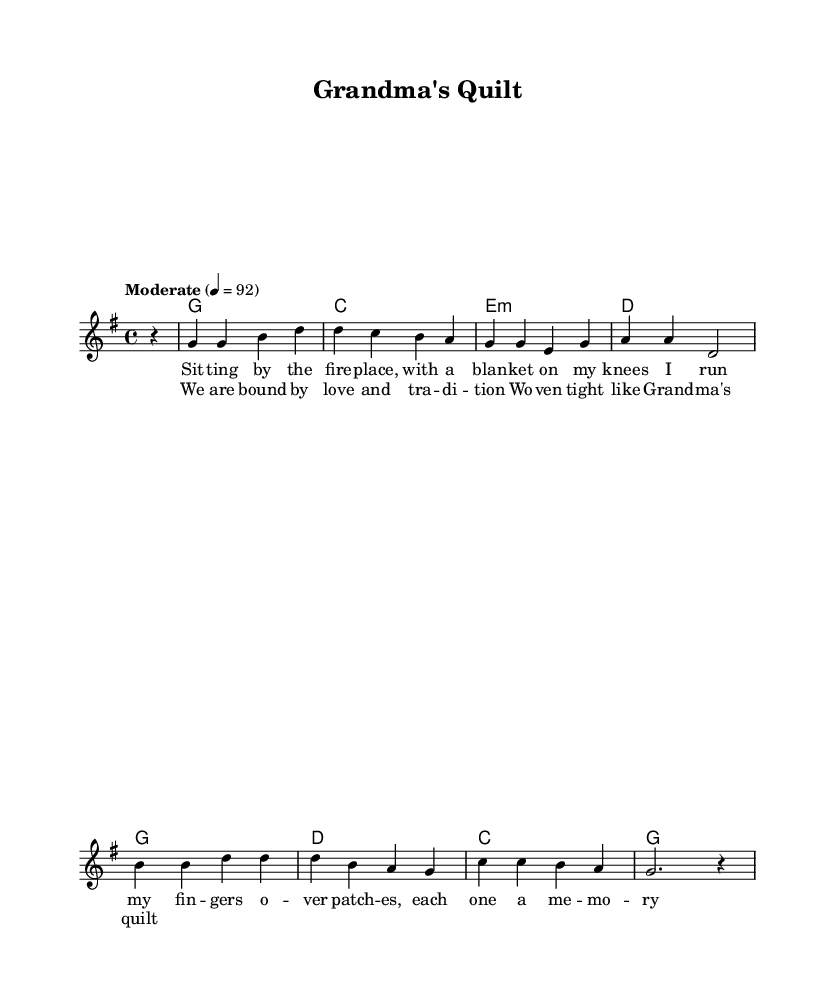What is the key signature of this music? The key signature is G major, which has one sharp (F#). You can identify the key signature in the music by looking at the set of sharps at the beginning of the staff. In this case, it is indicated by the placement of the sharps, which correspond to G major.
Answer: G major What is the time signature in this music? The time signature is 4/4, which indicates that there are four beats in each measure and a quarter note gets one beat. This can be seen at the beginning of the score, where the time signature is written as 4/4.
Answer: 4/4 What is the tempo marking for the piece? The tempo marking is "Moderate" and specifies a speed of quarter note at 92 beats per minute. This information is typically displayed right under the title or at the beginning of the musical notation. Here, it is clearly stated as instructing the performer on how quickly to play the piece.
Answer: Moderate, 92 How many measures are in the chorus? The chorus consists of four measures. This can be counted by looking at the staff lines and identifying where the bar lines are located. Each segment between bar lines represents one measure, and by counting them, we can determine the total.
Answer: 4 What is the thematic focus of the lyrics in verse one? The thematic focus of the lyrics in verse one is on family memories and warmth, as it describes sitting by the fireplace with a quilt that brings back memories. The imagery used in the lyrics reflects emotional connections and the nostalgia associated with family traditions.
Answer: Family memories What is the relationship between the lyrics in the verse and the chorus? The relationship is that both sections emphasize love and tradition; the verse describes personal memories while the chorus states that they are "bound by love and tradition." This reflects a strong emotional connection and a consistent theme throughout the song, tying the personal reflections to a broader sense of familial ties and heritage.
Answer: Love and tradition 